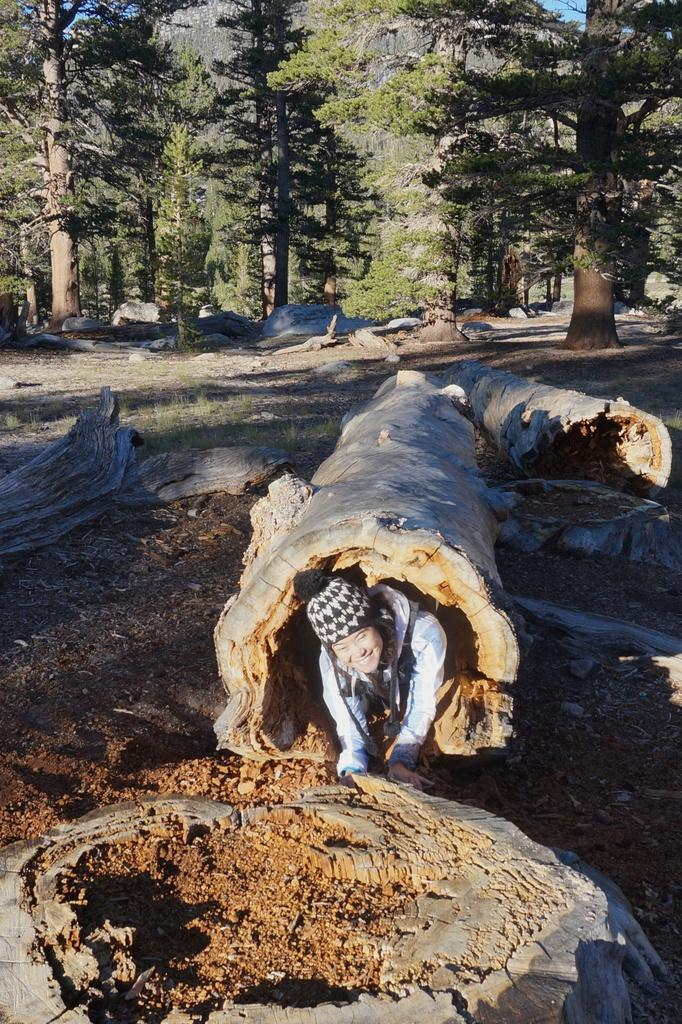What is the main subject in the foreground of the image? There is a person inside a log in the foreground of the image. What can be seen in the background of the image? There are trees, stones, and logs in the background of the image. What is visible in the sky in the background of the image? The sky is visible in the background of the image. What type of substance is the person using to write in a notebook in the image? There is no notebook or substance visible in the image; the person is inside a log. What type of animal can be seen interacting with the person inside the log in the image? There are no animals present in the image; the person is inside a log. 